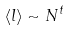<formula> <loc_0><loc_0><loc_500><loc_500>\langle l \rangle \sim N ^ { t }</formula> 